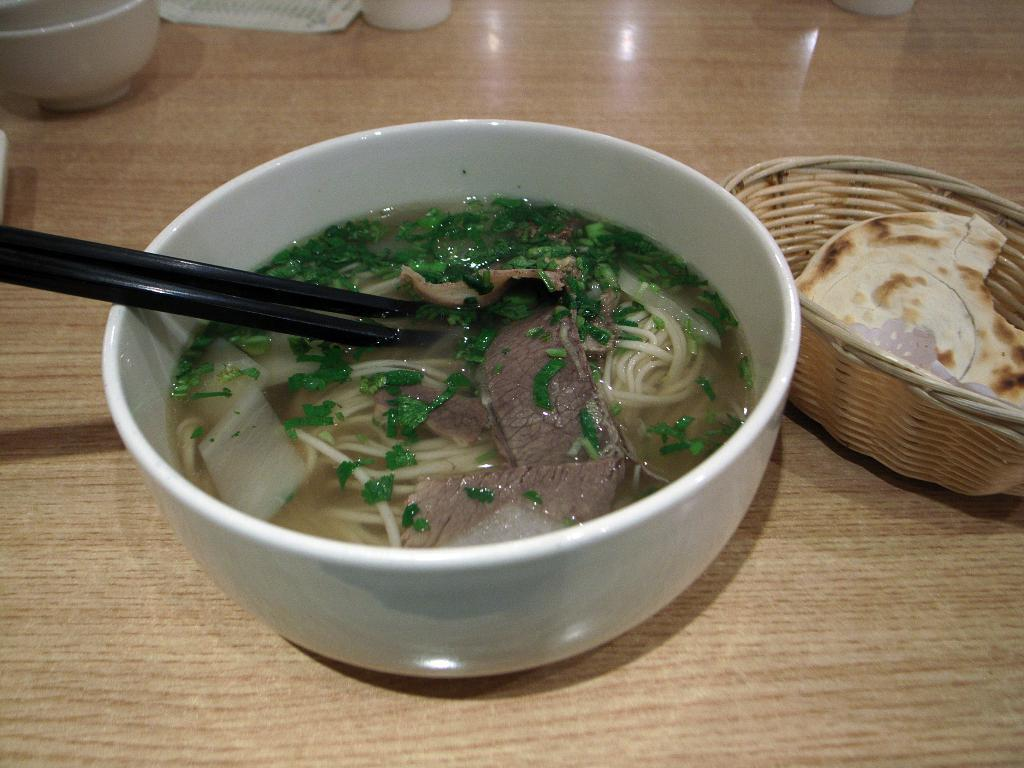What color is the bowl in the image? The bowl in the image is white. What is inside the white bowl? The bowl contains mutton soup. On what surface is the bowl placed? The bowl is placed on a wooden table top. What other object can be seen in the image besides the bowl? There is a small wooden basket in the image. What is inside the wooden basket? The basket contains a chapati. Where is the spot for the rake in the image? There is no rake or spot for a rake present in the image. What type of parcel is being delivered in the image? There is no parcel or delivery being depicted in the image. 